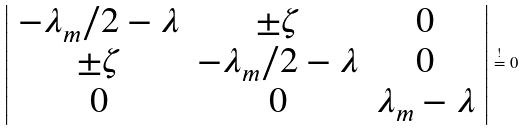<formula> <loc_0><loc_0><loc_500><loc_500>\left | \begin{array} { c c c } - \lambda _ { m } / 2 - \lambda & \pm \zeta & 0 \\ \pm \zeta & - \lambda _ { m } / 2 - \lambda & 0 \\ 0 & 0 & \lambda _ { m } - \lambda \end{array} \right | \stackrel { ! } { = } 0</formula> 